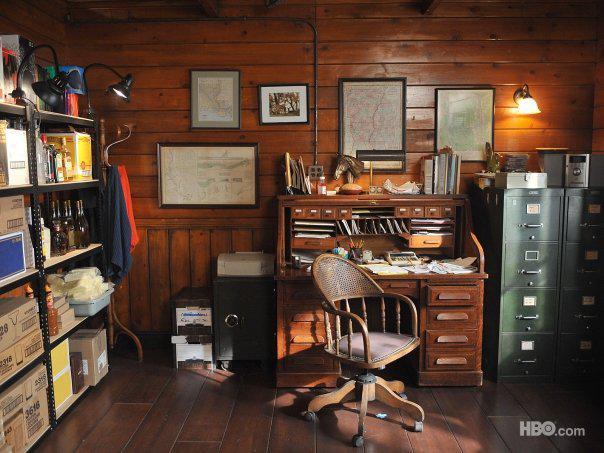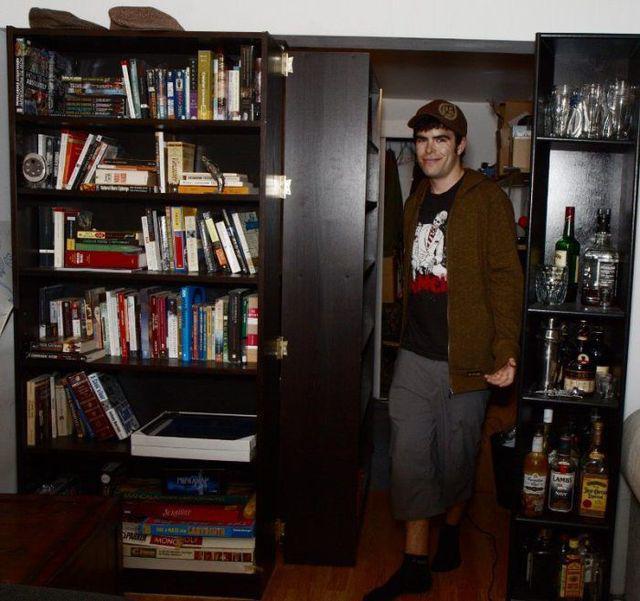The first image is the image on the left, the second image is the image on the right. Analyze the images presented: Is the assertion "A lamp is on in one of the images." valid? Answer yes or no. Yes. The first image is the image on the left, the second image is the image on the right. For the images shown, is this caption "in at least one image in the middle of a dark wall bookshelf is a wide tv." true? Answer yes or no. No. 